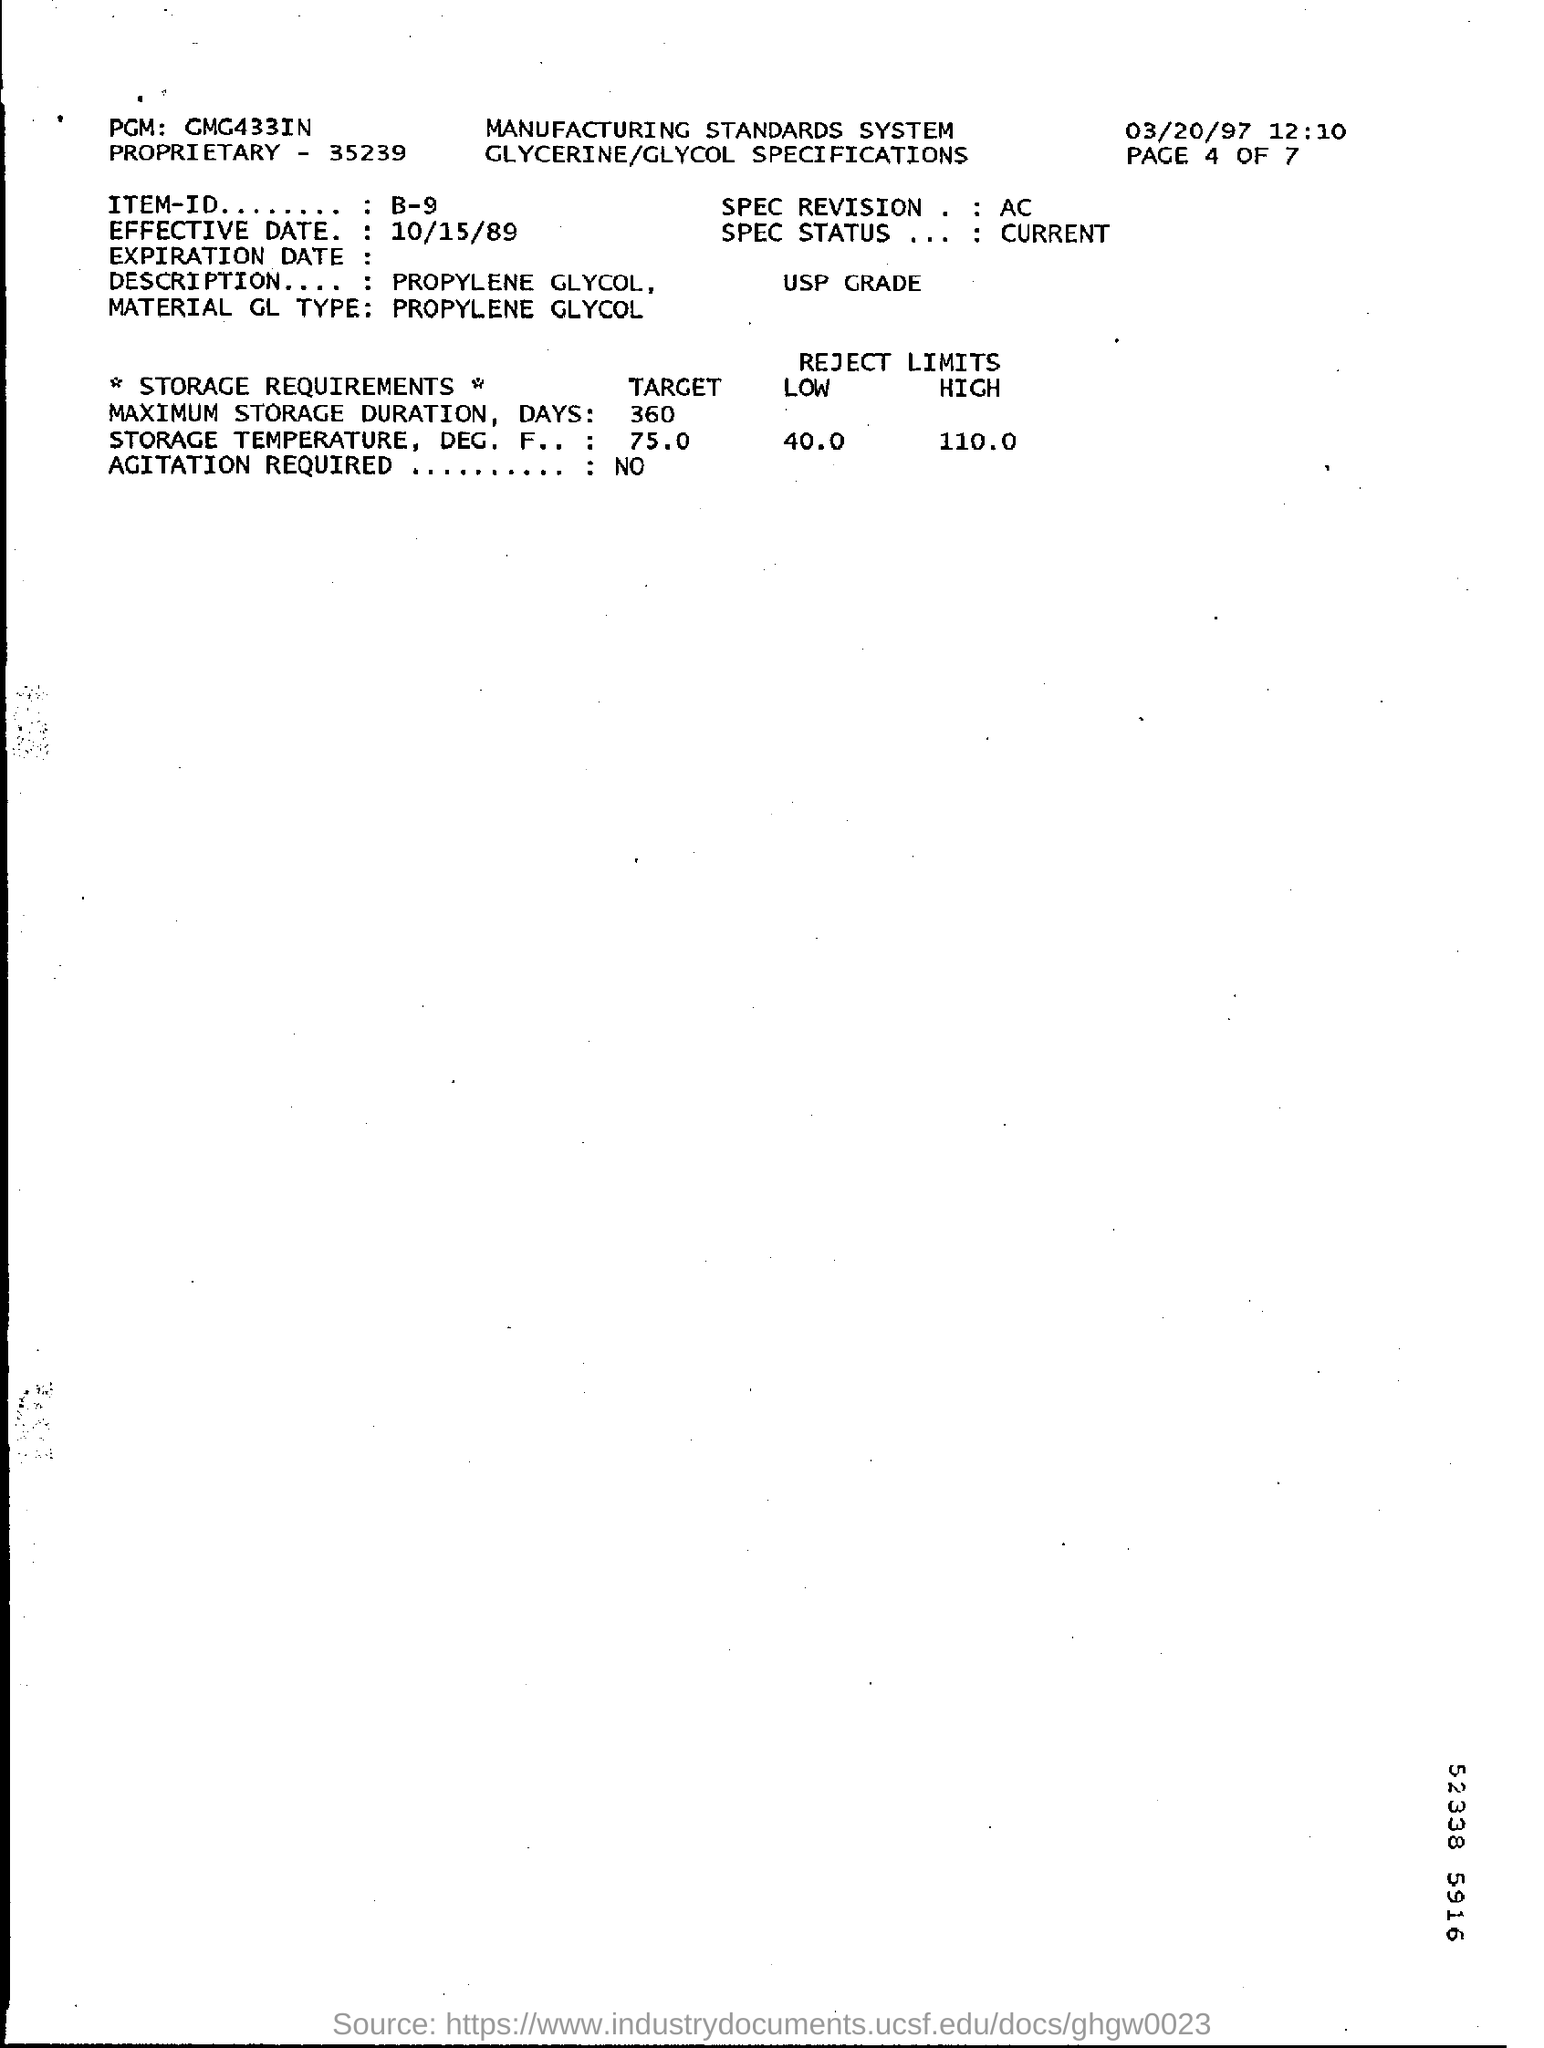Mention a couple of crucial points in this snapshot. The maximum storage duration in days is 360. The effective date mentioned in this document is October 15, 1989. The ITEM-ID mentioned in the document is B-9. The material is Propylene Glycol. 